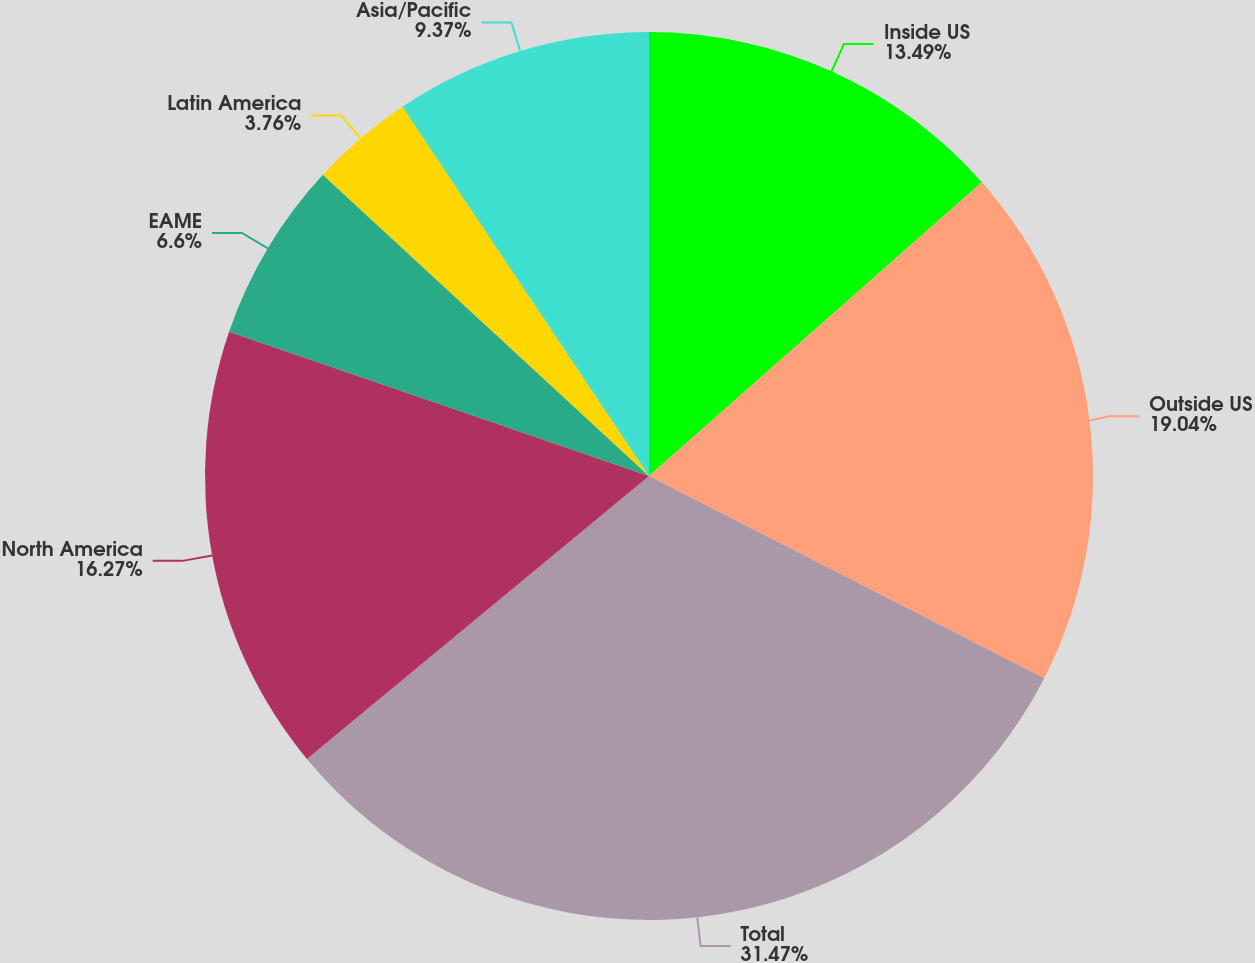Convert chart to OTSL. <chart><loc_0><loc_0><loc_500><loc_500><pie_chart><fcel>Inside US<fcel>Outside US<fcel>Total<fcel>North America<fcel>EAME<fcel>Latin America<fcel>Asia/Pacific<nl><fcel>13.49%<fcel>19.04%<fcel>31.47%<fcel>16.27%<fcel>6.6%<fcel>3.76%<fcel>9.37%<nl></chart> 